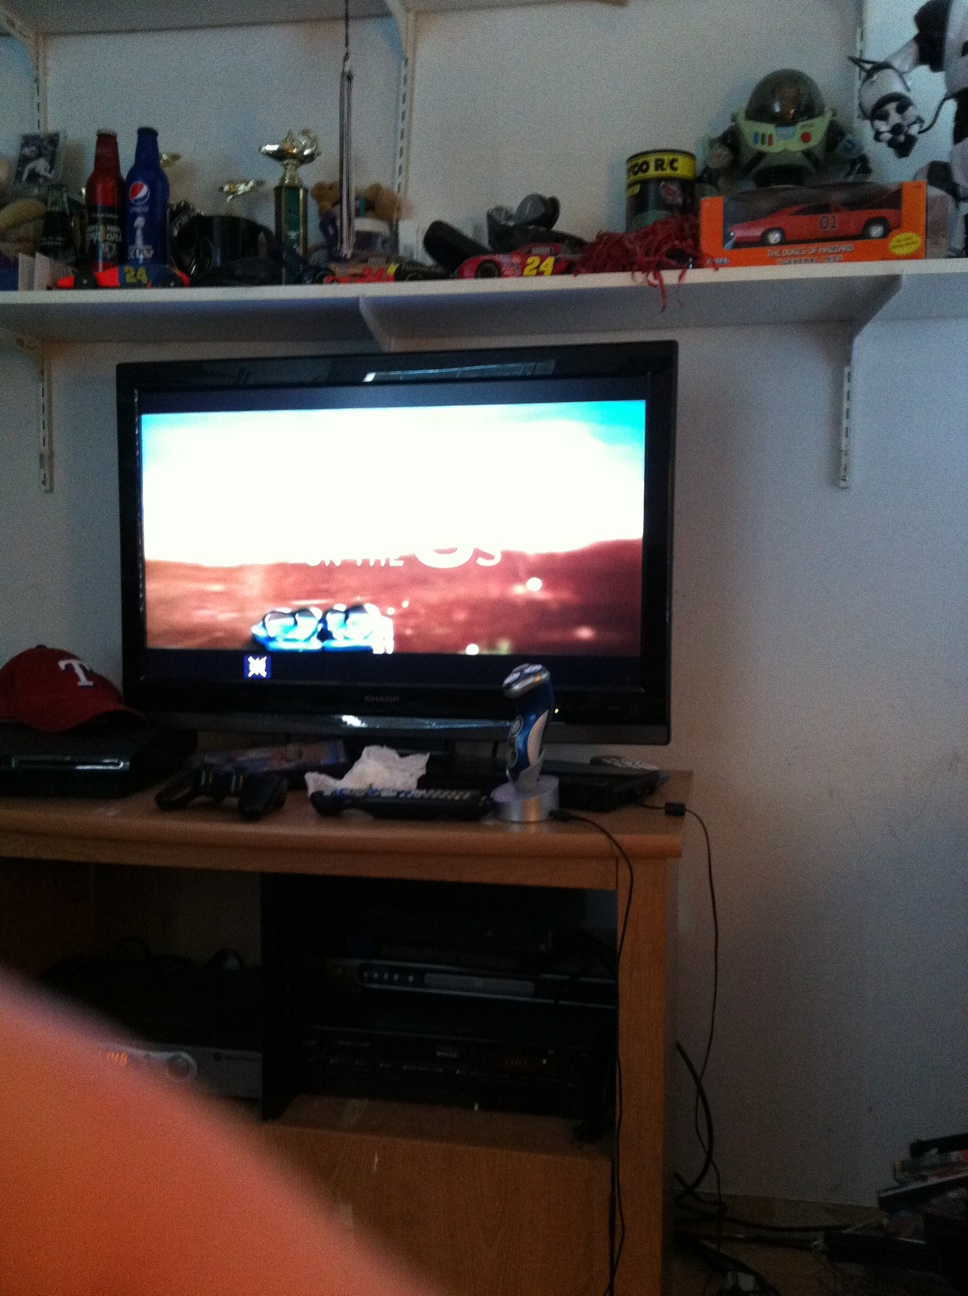Imagine what the room will look like in a hundred years. In a hundred years, this room will likely be transformed by advanced technology and futuristic design. The TV might be replaced by an interactive holographic display, showing content that is almost indistinguishable from reality. The shelves could be adorned with sophisticated gadgets and art pieces that reflect the aesthetics of the future. Yet, some things might remain the sharegpt4v/same - the love for collecting and displaying prized possessions, albeit more advanced, will likely persist, bridging the past and future in a nostalgic blend. 